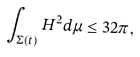Convert formula to latex. <formula><loc_0><loc_0><loc_500><loc_500>\int _ { \Sigma ( t ) } H ^ { 2 } d \mu \leq 3 2 \pi ,</formula> 